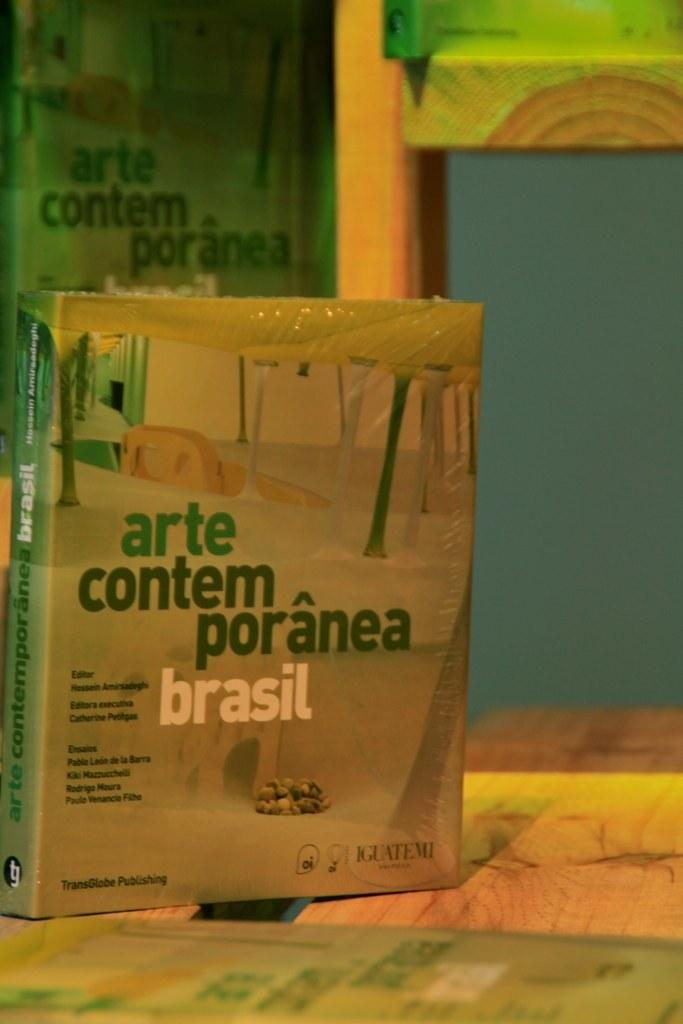<image>
Share a concise interpretation of the image provided. A book about Brasil that was published by TransGlobe Publishing. 